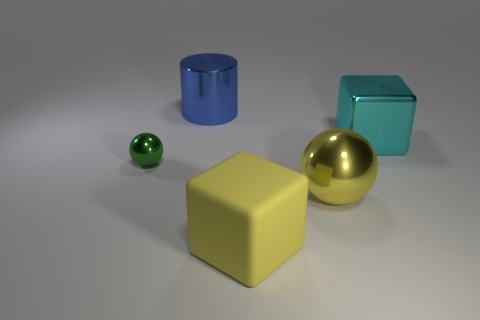Is there any other thing that is the same size as the green metallic object?
Your response must be concise. No. Is there any other thing that has the same material as the big yellow cube?
Provide a short and direct response. No. Do the ball that is on the right side of the matte cube and the cube that is on the left side of the cyan object have the same color?
Offer a very short reply. Yes. What is the color of the ball that is the same size as the matte object?
Keep it short and to the point. Yellow. Is there a large object of the same color as the big rubber cube?
Keep it short and to the point. Yes. There is a yellow object that is left of the yellow shiny object; does it have the same size as the green thing?
Your response must be concise. No. Are there the same number of big metal things left of the tiny object and tiny blue metal objects?
Offer a very short reply. Yes. What number of things are either big shiny things to the right of the large blue shiny thing or large blue metal things?
Your response must be concise. 3. What shape is the shiny object that is both right of the big shiny cylinder and to the left of the big cyan metallic cube?
Ensure brevity in your answer.  Sphere. How many things are metal objects that are behind the small metallic sphere or objects that are in front of the large blue thing?
Offer a terse response. 5. 